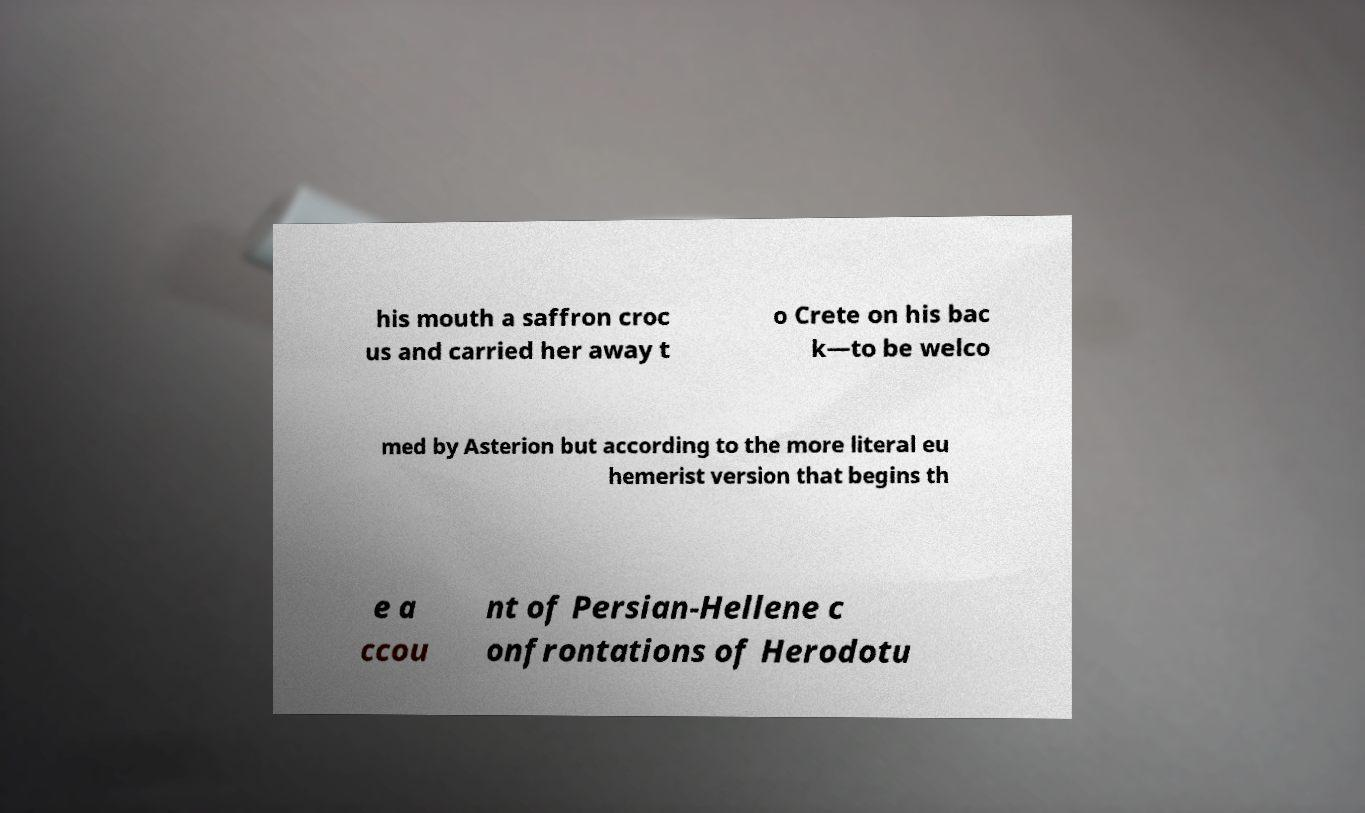What messages or text are displayed in this image? I need them in a readable, typed format. his mouth a saffron croc us and carried her away t o Crete on his bac k—to be welco med by Asterion but according to the more literal eu hemerist version that begins th e a ccou nt of Persian-Hellene c onfrontations of Herodotu 